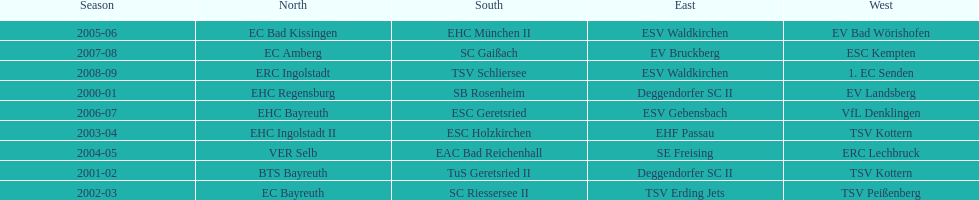What was the first club for the north in the 2000's? EHC Regensburg. 